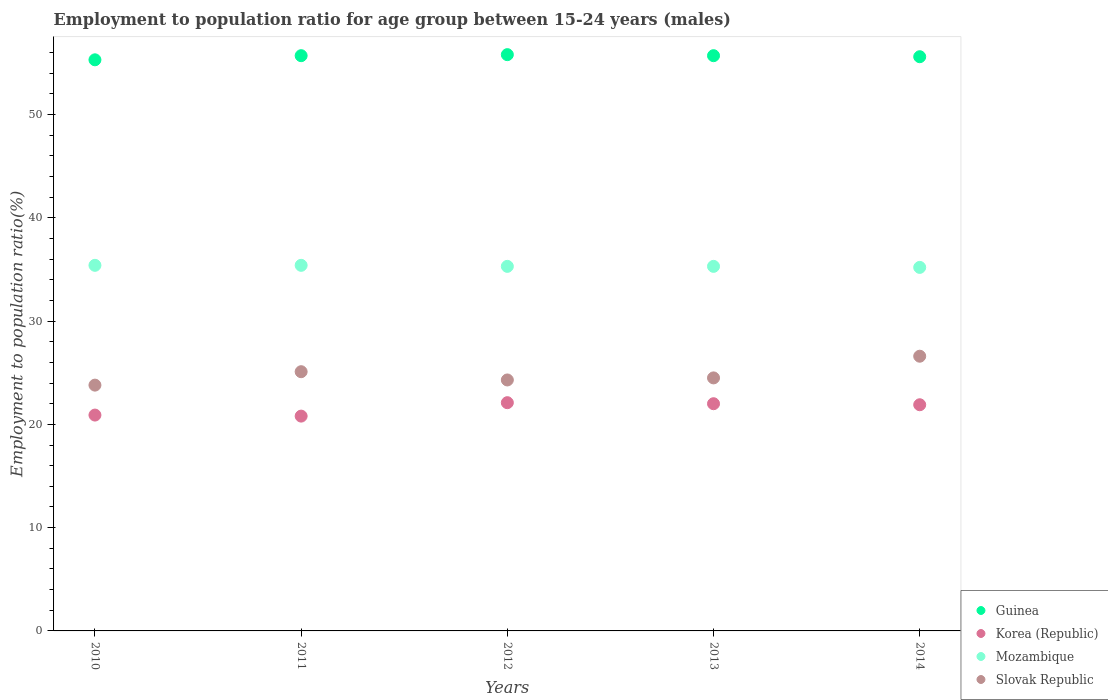Is the number of dotlines equal to the number of legend labels?
Keep it short and to the point. Yes. What is the employment to population ratio in Mozambique in 2013?
Your response must be concise. 35.3. Across all years, what is the maximum employment to population ratio in Korea (Republic)?
Make the answer very short. 22.1. Across all years, what is the minimum employment to population ratio in Slovak Republic?
Keep it short and to the point. 23.8. In which year was the employment to population ratio in Slovak Republic maximum?
Your answer should be very brief. 2014. In which year was the employment to population ratio in Korea (Republic) minimum?
Offer a terse response. 2011. What is the total employment to population ratio in Guinea in the graph?
Provide a succinct answer. 278.1. What is the difference between the employment to population ratio in Guinea in 2013 and that in 2014?
Your response must be concise. 0.1. What is the difference between the employment to population ratio in Guinea in 2013 and the employment to population ratio in Mozambique in 2014?
Give a very brief answer. 20.5. What is the average employment to population ratio in Slovak Republic per year?
Provide a succinct answer. 24.86. In the year 2010, what is the difference between the employment to population ratio in Korea (Republic) and employment to population ratio in Mozambique?
Provide a short and direct response. -14.5. What is the ratio of the employment to population ratio in Korea (Republic) in 2011 to that in 2012?
Your response must be concise. 0.94. What is the difference between the highest and the second highest employment to population ratio in Guinea?
Provide a short and direct response. 0.1. What is the difference between the highest and the lowest employment to population ratio in Guinea?
Your answer should be compact. 0.5. Is it the case that in every year, the sum of the employment to population ratio in Korea (Republic) and employment to population ratio in Slovak Republic  is greater than the sum of employment to population ratio in Mozambique and employment to population ratio in Guinea?
Offer a very short reply. No. Is it the case that in every year, the sum of the employment to population ratio in Korea (Republic) and employment to population ratio in Guinea  is greater than the employment to population ratio in Mozambique?
Give a very brief answer. Yes. What is the difference between two consecutive major ticks on the Y-axis?
Your answer should be compact. 10. Does the graph contain any zero values?
Ensure brevity in your answer.  No. Does the graph contain grids?
Keep it short and to the point. No. What is the title of the graph?
Provide a short and direct response. Employment to population ratio for age group between 15-24 years (males). What is the label or title of the Y-axis?
Offer a very short reply. Employment to population ratio(%). What is the Employment to population ratio(%) in Guinea in 2010?
Ensure brevity in your answer.  55.3. What is the Employment to population ratio(%) in Korea (Republic) in 2010?
Provide a short and direct response. 20.9. What is the Employment to population ratio(%) of Mozambique in 2010?
Your answer should be compact. 35.4. What is the Employment to population ratio(%) in Slovak Republic in 2010?
Provide a short and direct response. 23.8. What is the Employment to population ratio(%) in Guinea in 2011?
Provide a short and direct response. 55.7. What is the Employment to population ratio(%) of Korea (Republic) in 2011?
Offer a terse response. 20.8. What is the Employment to population ratio(%) in Mozambique in 2011?
Your answer should be very brief. 35.4. What is the Employment to population ratio(%) of Slovak Republic in 2011?
Offer a terse response. 25.1. What is the Employment to population ratio(%) of Guinea in 2012?
Provide a succinct answer. 55.8. What is the Employment to population ratio(%) of Korea (Republic) in 2012?
Ensure brevity in your answer.  22.1. What is the Employment to population ratio(%) of Mozambique in 2012?
Offer a terse response. 35.3. What is the Employment to population ratio(%) of Slovak Republic in 2012?
Offer a terse response. 24.3. What is the Employment to population ratio(%) in Guinea in 2013?
Offer a terse response. 55.7. What is the Employment to population ratio(%) in Korea (Republic) in 2013?
Give a very brief answer. 22. What is the Employment to population ratio(%) of Mozambique in 2013?
Your answer should be very brief. 35.3. What is the Employment to population ratio(%) in Guinea in 2014?
Offer a terse response. 55.6. What is the Employment to population ratio(%) of Korea (Republic) in 2014?
Ensure brevity in your answer.  21.9. What is the Employment to population ratio(%) of Mozambique in 2014?
Provide a succinct answer. 35.2. What is the Employment to population ratio(%) of Slovak Republic in 2014?
Ensure brevity in your answer.  26.6. Across all years, what is the maximum Employment to population ratio(%) of Guinea?
Offer a very short reply. 55.8. Across all years, what is the maximum Employment to population ratio(%) in Korea (Republic)?
Give a very brief answer. 22.1. Across all years, what is the maximum Employment to population ratio(%) in Mozambique?
Your response must be concise. 35.4. Across all years, what is the maximum Employment to population ratio(%) in Slovak Republic?
Give a very brief answer. 26.6. Across all years, what is the minimum Employment to population ratio(%) of Guinea?
Provide a short and direct response. 55.3. Across all years, what is the minimum Employment to population ratio(%) of Korea (Republic)?
Keep it short and to the point. 20.8. Across all years, what is the minimum Employment to population ratio(%) of Mozambique?
Your answer should be compact. 35.2. Across all years, what is the minimum Employment to population ratio(%) in Slovak Republic?
Give a very brief answer. 23.8. What is the total Employment to population ratio(%) of Guinea in the graph?
Keep it short and to the point. 278.1. What is the total Employment to population ratio(%) in Korea (Republic) in the graph?
Give a very brief answer. 107.7. What is the total Employment to population ratio(%) in Mozambique in the graph?
Provide a succinct answer. 176.6. What is the total Employment to population ratio(%) of Slovak Republic in the graph?
Offer a terse response. 124.3. What is the difference between the Employment to population ratio(%) in Korea (Republic) in 2010 and that in 2011?
Provide a succinct answer. 0.1. What is the difference between the Employment to population ratio(%) in Mozambique in 2010 and that in 2012?
Offer a terse response. 0.1. What is the difference between the Employment to population ratio(%) in Slovak Republic in 2010 and that in 2012?
Provide a succinct answer. -0.5. What is the difference between the Employment to population ratio(%) of Guinea in 2010 and that in 2013?
Ensure brevity in your answer.  -0.4. What is the difference between the Employment to population ratio(%) of Korea (Republic) in 2010 and that in 2013?
Keep it short and to the point. -1.1. What is the difference between the Employment to population ratio(%) in Mozambique in 2010 and that in 2013?
Keep it short and to the point. 0.1. What is the difference between the Employment to population ratio(%) in Slovak Republic in 2010 and that in 2013?
Offer a very short reply. -0.7. What is the difference between the Employment to population ratio(%) in Guinea in 2010 and that in 2014?
Your answer should be compact. -0.3. What is the difference between the Employment to population ratio(%) in Mozambique in 2010 and that in 2014?
Provide a succinct answer. 0.2. What is the difference between the Employment to population ratio(%) of Slovak Republic in 2010 and that in 2014?
Make the answer very short. -2.8. What is the difference between the Employment to population ratio(%) of Guinea in 2011 and that in 2013?
Ensure brevity in your answer.  0. What is the difference between the Employment to population ratio(%) of Korea (Republic) in 2011 and that in 2013?
Your answer should be very brief. -1.2. What is the difference between the Employment to population ratio(%) in Mozambique in 2011 and that in 2013?
Provide a short and direct response. 0.1. What is the difference between the Employment to population ratio(%) in Guinea in 2011 and that in 2014?
Provide a short and direct response. 0.1. What is the difference between the Employment to population ratio(%) in Korea (Republic) in 2011 and that in 2014?
Offer a very short reply. -1.1. What is the difference between the Employment to population ratio(%) of Mozambique in 2011 and that in 2014?
Give a very brief answer. 0.2. What is the difference between the Employment to population ratio(%) of Slovak Republic in 2011 and that in 2014?
Offer a terse response. -1.5. What is the difference between the Employment to population ratio(%) in Guinea in 2012 and that in 2013?
Your response must be concise. 0.1. What is the difference between the Employment to population ratio(%) in Slovak Republic in 2012 and that in 2013?
Keep it short and to the point. -0.2. What is the difference between the Employment to population ratio(%) in Guinea in 2012 and that in 2014?
Your answer should be compact. 0.2. What is the difference between the Employment to population ratio(%) in Mozambique in 2012 and that in 2014?
Provide a short and direct response. 0.1. What is the difference between the Employment to population ratio(%) of Slovak Republic in 2012 and that in 2014?
Offer a terse response. -2.3. What is the difference between the Employment to population ratio(%) in Mozambique in 2013 and that in 2014?
Offer a terse response. 0.1. What is the difference between the Employment to population ratio(%) in Guinea in 2010 and the Employment to population ratio(%) in Korea (Republic) in 2011?
Provide a succinct answer. 34.5. What is the difference between the Employment to population ratio(%) in Guinea in 2010 and the Employment to population ratio(%) in Mozambique in 2011?
Give a very brief answer. 19.9. What is the difference between the Employment to population ratio(%) of Guinea in 2010 and the Employment to population ratio(%) of Slovak Republic in 2011?
Your answer should be very brief. 30.2. What is the difference between the Employment to population ratio(%) in Mozambique in 2010 and the Employment to population ratio(%) in Slovak Republic in 2011?
Ensure brevity in your answer.  10.3. What is the difference between the Employment to population ratio(%) of Guinea in 2010 and the Employment to population ratio(%) of Korea (Republic) in 2012?
Your answer should be very brief. 33.2. What is the difference between the Employment to population ratio(%) in Guinea in 2010 and the Employment to population ratio(%) in Mozambique in 2012?
Make the answer very short. 20. What is the difference between the Employment to population ratio(%) in Guinea in 2010 and the Employment to population ratio(%) in Slovak Republic in 2012?
Offer a very short reply. 31. What is the difference between the Employment to population ratio(%) of Korea (Republic) in 2010 and the Employment to population ratio(%) of Mozambique in 2012?
Provide a short and direct response. -14.4. What is the difference between the Employment to population ratio(%) in Korea (Republic) in 2010 and the Employment to population ratio(%) in Slovak Republic in 2012?
Provide a succinct answer. -3.4. What is the difference between the Employment to population ratio(%) in Guinea in 2010 and the Employment to population ratio(%) in Korea (Republic) in 2013?
Make the answer very short. 33.3. What is the difference between the Employment to population ratio(%) in Guinea in 2010 and the Employment to population ratio(%) in Mozambique in 2013?
Offer a very short reply. 20. What is the difference between the Employment to population ratio(%) of Guinea in 2010 and the Employment to population ratio(%) of Slovak Republic in 2013?
Give a very brief answer. 30.8. What is the difference between the Employment to population ratio(%) in Korea (Republic) in 2010 and the Employment to population ratio(%) in Mozambique in 2013?
Your answer should be compact. -14.4. What is the difference between the Employment to population ratio(%) of Mozambique in 2010 and the Employment to population ratio(%) of Slovak Republic in 2013?
Make the answer very short. 10.9. What is the difference between the Employment to population ratio(%) in Guinea in 2010 and the Employment to population ratio(%) in Korea (Republic) in 2014?
Your response must be concise. 33.4. What is the difference between the Employment to population ratio(%) of Guinea in 2010 and the Employment to population ratio(%) of Mozambique in 2014?
Provide a short and direct response. 20.1. What is the difference between the Employment to population ratio(%) in Guinea in 2010 and the Employment to population ratio(%) in Slovak Republic in 2014?
Your response must be concise. 28.7. What is the difference between the Employment to population ratio(%) in Korea (Republic) in 2010 and the Employment to population ratio(%) in Mozambique in 2014?
Provide a short and direct response. -14.3. What is the difference between the Employment to population ratio(%) of Korea (Republic) in 2010 and the Employment to population ratio(%) of Slovak Republic in 2014?
Offer a very short reply. -5.7. What is the difference between the Employment to population ratio(%) of Guinea in 2011 and the Employment to population ratio(%) of Korea (Republic) in 2012?
Provide a short and direct response. 33.6. What is the difference between the Employment to population ratio(%) of Guinea in 2011 and the Employment to population ratio(%) of Mozambique in 2012?
Your answer should be very brief. 20.4. What is the difference between the Employment to population ratio(%) of Guinea in 2011 and the Employment to population ratio(%) of Slovak Republic in 2012?
Provide a short and direct response. 31.4. What is the difference between the Employment to population ratio(%) in Korea (Republic) in 2011 and the Employment to population ratio(%) in Mozambique in 2012?
Make the answer very short. -14.5. What is the difference between the Employment to population ratio(%) in Mozambique in 2011 and the Employment to population ratio(%) in Slovak Republic in 2012?
Provide a short and direct response. 11.1. What is the difference between the Employment to population ratio(%) of Guinea in 2011 and the Employment to population ratio(%) of Korea (Republic) in 2013?
Your answer should be compact. 33.7. What is the difference between the Employment to population ratio(%) of Guinea in 2011 and the Employment to population ratio(%) of Mozambique in 2013?
Your answer should be very brief. 20.4. What is the difference between the Employment to population ratio(%) in Guinea in 2011 and the Employment to population ratio(%) in Slovak Republic in 2013?
Your answer should be compact. 31.2. What is the difference between the Employment to population ratio(%) of Korea (Republic) in 2011 and the Employment to population ratio(%) of Mozambique in 2013?
Make the answer very short. -14.5. What is the difference between the Employment to population ratio(%) of Guinea in 2011 and the Employment to population ratio(%) of Korea (Republic) in 2014?
Ensure brevity in your answer.  33.8. What is the difference between the Employment to population ratio(%) in Guinea in 2011 and the Employment to population ratio(%) in Mozambique in 2014?
Ensure brevity in your answer.  20.5. What is the difference between the Employment to population ratio(%) in Guinea in 2011 and the Employment to population ratio(%) in Slovak Republic in 2014?
Your response must be concise. 29.1. What is the difference between the Employment to population ratio(%) of Korea (Republic) in 2011 and the Employment to population ratio(%) of Mozambique in 2014?
Keep it short and to the point. -14.4. What is the difference between the Employment to population ratio(%) of Korea (Republic) in 2011 and the Employment to population ratio(%) of Slovak Republic in 2014?
Give a very brief answer. -5.8. What is the difference between the Employment to population ratio(%) in Guinea in 2012 and the Employment to population ratio(%) in Korea (Republic) in 2013?
Your answer should be compact. 33.8. What is the difference between the Employment to population ratio(%) in Guinea in 2012 and the Employment to population ratio(%) in Mozambique in 2013?
Provide a succinct answer. 20.5. What is the difference between the Employment to population ratio(%) in Guinea in 2012 and the Employment to population ratio(%) in Slovak Republic in 2013?
Ensure brevity in your answer.  31.3. What is the difference between the Employment to population ratio(%) in Korea (Republic) in 2012 and the Employment to population ratio(%) in Slovak Republic in 2013?
Your answer should be compact. -2.4. What is the difference between the Employment to population ratio(%) in Guinea in 2012 and the Employment to population ratio(%) in Korea (Republic) in 2014?
Give a very brief answer. 33.9. What is the difference between the Employment to population ratio(%) in Guinea in 2012 and the Employment to population ratio(%) in Mozambique in 2014?
Keep it short and to the point. 20.6. What is the difference between the Employment to population ratio(%) of Guinea in 2012 and the Employment to population ratio(%) of Slovak Republic in 2014?
Your answer should be compact. 29.2. What is the difference between the Employment to population ratio(%) in Mozambique in 2012 and the Employment to population ratio(%) in Slovak Republic in 2014?
Provide a short and direct response. 8.7. What is the difference between the Employment to population ratio(%) of Guinea in 2013 and the Employment to population ratio(%) of Korea (Republic) in 2014?
Keep it short and to the point. 33.8. What is the difference between the Employment to population ratio(%) in Guinea in 2013 and the Employment to population ratio(%) in Slovak Republic in 2014?
Provide a succinct answer. 29.1. What is the difference between the Employment to population ratio(%) in Korea (Republic) in 2013 and the Employment to population ratio(%) in Mozambique in 2014?
Ensure brevity in your answer.  -13.2. What is the difference between the Employment to population ratio(%) in Mozambique in 2013 and the Employment to population ratio(%) in Slovak Republic in 2014?
Give a very brief answer. 8.7. What is the average Employment to population ratio(%) of Guinea per year?
Your response must be concise. 55.62. What is the average Employment to population ratio(%) in Korea (Republic) per year?
Your response must be concise. 21.54. What is the average Employment to population ratio(%) of Mozambique per year?
Provide a short and direct response. 35.32. What is the average Employment to population ratio(%) in Slovak Republic per year?
Keep it short and to the point. 24.86. In the year 2010, what is the difference between the Employment to population ratio(%) of Guinea and Employment to population ratio(%) of Korea (Republic)?
Keep it short and to the point. 34.4. In the year 2010, what is the difference between the Employment to population ratio(%) of Guinea and Employment to population ratio(%) of Mozambique?
Offer a terse response. 19.9. In the year 2010, what is the difference between the Employment to population ratio(%) in Guinea and Employment to population ratio(%) in Slovak Republic?
Offer a very short reply. 31.5. In the year 2010, what is the difference between the Employment to population ratio(%) in Mozambique and Employment to population ratio(%) in Slovak Republic?
Make the answer very short. 11.6. In the year 2011, what is the difference between the Employment to population ratio(%) in Guinea and Employment to population ratio(%) in Korea (Republic)?
Make the answer very short. 34.9. In the year 2011, what is the difference between the Employment to population ratio(%) of Guinea and Employment to population ratio(%) of Mozambique?
Your answer should be very brief. 20.3. In the year 2011, what is the difference between the Employment to population ratio(%) in Guinea and Employment to population ratio(%) in Slovak Republic?
Provide a short and direct response. 30.6. In the year 2011, what is the difference between the Employment to population ratio(%) in Korea (Republic) and Employment to population ratio(%) in Mozambique?
Give a very brief answer. -14.6. In the year 2011, what is the difference between the Employment to population ratio(%) of Korea (Republic) and Employment to population ratio(%) of Slovak Republic?
Your response must be concise. -4.3. In the year 2011, what is the difference between the Employment to population ratio(%) of Mozambique and Employment to population ratio(%) of Slovak Republic?
Your answer should be very brief. 10.3. In the year 2012, what is the difference between the Employment to population ratio(%) of Guinea and Employment to population ratio(%) of Korea (Republic)?
Provide a succinct answer. 33.7. In the year 2012, what is the difference between the Employment to population ratio(%) in Guinea and Employment to population ratio(%) in Mozambique?
Offer a very short reply. 20.5. In the year 2012, what is the difference between the Employment to population ratio(%) of Guinea and Employment to population ratio(%) of Slovak Republic?
Provide a short and direct response. 31.5. In the year 2012, what is the difference between the Employment to population ratio(%) in Korea (Republic) and Employment to population ratio(%) in Slovak Republic?
Your answer should be compact. -2.2. In the year 2013, what is the difference between the Employment to population ratio(%) in Guinea and Employment to population ratio(%) in Korea (Republic)?
Make the answer very short. 33.7. In the year 2013, what is the difference between the Employment to population ratio(%) of Guinea and Employment to population ratio(%) of Mozambique?
Ensure brevity in your answer.  20.4. In the year 2013, what is the difference between the Employment to population ratio(%) of Guinea and Employment to population ratio(%) of Slovak Republic?
Your answer should be very brief. 31.2. In the year 2013, what is the difference between the Employment to population ratio(%) of Korea (Republic) and Employment to population ratio(%) of Slovak Republic?
Offer a very short reply. -2.5. In the year 2013, what is the difference between the Employment to population ratio(%) of Mozambique and Employment to population ratio(%) of Slovak Republic?
Give a very brief answer. 10.8. In the year 2014, what is the difference between the Employment to population ratio(%) in Guinea and Employment to population ratio(%) in Korea (Republic)?
Your answer should be very brief. 33.7. In the year 2014, what is the difference between the Employment to population ratio(%) in Guinea and Employment to population ratio(%) in Mozambique?
Offer a terse response. 20.4. In the year 2014, what is the difference between the Employment to population ratio(%) of Korea (Republic) and Employment to population ratio(%) of Mozambique?
Give a very brief answer. -13.3. In the year 2014, what is the difference between the Employment to population ratio(%) of Korea (Republic) and Employment to population ratio(%) of Slovak Republic?
Your response must be concise. -4.7. In the year 2014, what is the difference between the Employment to population ratio(%) in Mozambique and Employment to population ratio(%) in Slovak Republic?
Ensure brevity in your answer.  8.6. What is the ratio of the Employment to population ratio(%) in Mozambique in 2010 to that in 2011?
Give a very brief answer. 1. What is the ratio of the Employment to population ratio(%) in Slovak Republic in 2010 to that in 2011?
Provide a succinct answer. 0.95. What is the ratio of the Employment to population ratio(%) in Guinea in 2010 to that in 2012?
Your answer should be very brief. 0.99. What is the ratio of the Employment to population ratio(%) in Korea (Republic) in 2010 to that in 2012?
Keep it short and to the point. 0.95. What is the ratio of the Employment to population ratio(%) of Mozambique in 2010 to that in 2012?
Provide a succinct answer. 1. What is the ratio of the Employment to population ratio(%) of Slovak Republic in 2010 to that in 2012?
Ensure brevity in your answer.  0.98. What is the ratio of the Employment to population ratio(%) in Korea (Republic) in 2010 to that in 2013?
Give a very brief answer. 0.95. What is the ratio of the Employment to population ratio(%) of Mozambique in 2010 to that in 2013?
Provide a succinct answer. 1. What is the ratio of the Employment to population ratio(%) in Slovak Republic in 2010 to that in 2013?
Your answer should be compact. 0.97. What is the ratio of the Employment to population ratio(%) of Korea (Republic) in 2010 to that in 2014?
Make the answer very short. 0.95. What is the ratio of the Employment to population ratio(%) in Mozambique in 2010 to that in 2014?
Give a very brief answer. 1.01. What is the ratio of the Employment to population ratio(%) of Slovak Republic in 2010 to that in 2014?
Make the answer very short. 0.89. What is the ratio of the Employment to population ratio(%) of Guinea in 2011 to that in 2012?
Give a very brief answer. 1. What is the ratio of the Employment to population ratio(%) of Mozambique in 2011 to that in 2012?
Provide a succinct answer. 1. What is the ratio of the Employment to population ratio(%) in Slovak Republic in 2011 to that in 2012?
Give a very brief answer. 1.03. What is the ratio of the Employment to population ratio(%) of Korea (Republic) in 2011 to that in 2013?
Your answer should be compact. 0.95. What is the ratio of the Employment to population ratio(%) of Mozambique in 2011 to that in 2013?
Provide a short and direct response. 1. What is the ratio of the Employment to population ratio(%) of Slovak Republic in 2011 to that in 2013?
Provide a succinct answer. 1.02. What is the ratio of the Employment to population ratio(%) in Guinea in 2011 to that in 2014?
Ensure brevity in your answer.  1. What is the ratio of the Employment to population ratio(%) in Korea (Republic) in 2011 to that in 2014?
Your answer should be compact. 0.95. What is the ratio of the Employment to population ratio(%) of Slovak Republic in 2011 to that in 2014?
Your answer should be very brief. 0.94. What is the ratio of the Employment to population ratio(%) of Guinea in 2012 to that in 2013?
Provide a short and direct response. 1. What is the ratio of the Employment to population ratio(%) of Korea (Republic) in 2012 to that in 2013?
Your response must be concise. 1. What is the ratio of the Employment to population ratio(%) in Guinea in 2012 to that in 2014?
Your answer should be very brief. 1. What is the ratio of the Employment to population ratio(%) in Korea (Republic) in 2012 to that in 2014?
Give a very brief answer. 1.01. What is the ratio of the Employment to population ratio(%) in Slovak Republic in 2012 to that in 2014?
Keep it short and to the point. 0.91. What is the ratio of the Employment to population ratio(%) in Guinea in 2013 to that in 2014?
Your answer should be compact. 1. What is the ratio of the Employment to population ratio(%) of Slovak Republic in 2013 to that in 2014?
Offer a terse response. 0.92. What is the difference between the highest and the second highest Employment to population ratio(%) in Guinea?
Offer a terse response. 0.1. What is the difference between the highest and the second highest Employment to population ratio(%) in Korea (Republic)?
Your answer should be very brief. 0.1. What is the difference between the highest and the second highest Employment to population ratio(%) in Mozambique?
Your answer should be very brief. 0. What is the difference between the highest and the lowest Employment to population ratio(%) of Mozambique?
Offer a very short reply. 0.2. What is the difference between the highest and the lowest Employment to population ratio(%) of Slovak Republic?
Make the answer very short. 2.8. 